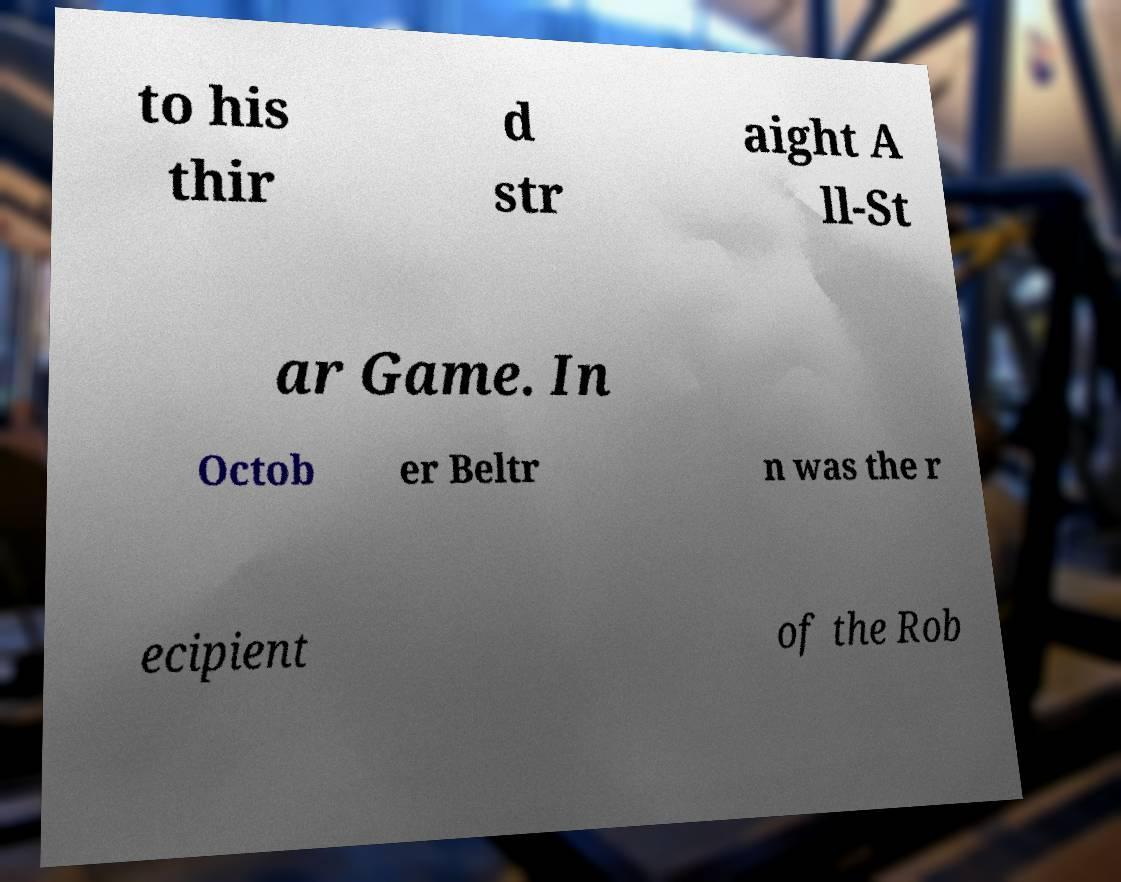For documentation purposes, I need the text within this image transcribed. Could you provide that? to his thir d str aight A ll-St ar Game. In Octob er Beltr n was the r ecipient of the Rob 